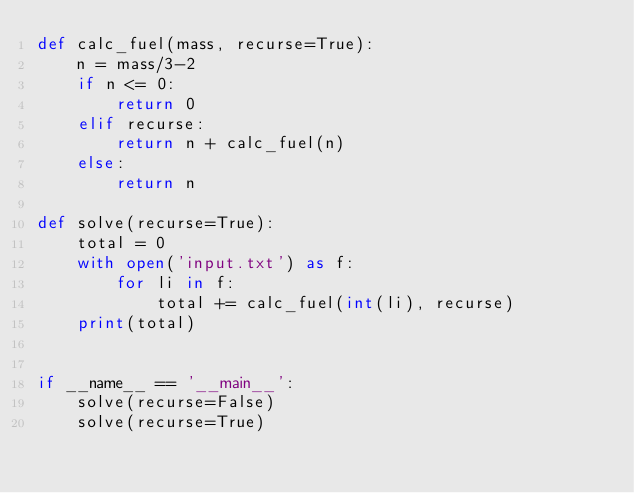Convert code to text. <code><loc_0><loc_0><loc_500><loc_500><_Python_>def calc_fuel(mass, recurse=True):
    n = mass/3-2
    if n <= 0:
        return 0
    elif recurse:
        return n + calc_fuel(n)
    else:
        return n

def solve(recurse=True):
    total = 0
    with open('input.txt') as f:
        for li in f:
            total += calc_fuel(int(li), recurse)
    print(total)


if __name__ == '__main__':
    solve(recurse=False)
    solve(recurse=True)
</code> 